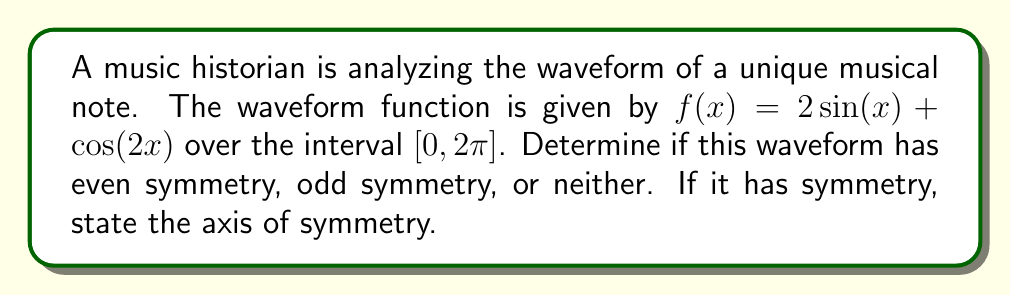Help me with this question. To determine the symmetry of the waveform function $f(x) = 2\sin(x) + \cos(2x)$, we need to check if it satisfies the conditions for even or odd symmetry:

1. Even symmetry: $f(-x) = f(x)$ for all $x$ in the domain
2. Odd symmetry: $f(-x) = -f(x)$ for all $x$ in the domain

Let's examine each term of the function:

1. $2\sin(x)$:
   $\sin(-x) = -\sin(x)$, so this term has odd symmetry.

2. $\cos(2x)$:
   $\cos(-2x) = \cos(2x)$, so this term has even symmetry.

Since the function is a sum of an odd function and an even function, it doesn't have overall even or odd symmetry.

However, we can check for symmetry about the y-axis (x = 0) or the origin:

For y-axis symmetry (even symmetry):
$f(-x) = 2\sin(-x) + \cos(-2x) = -2\sin(x) + \cos(2x) \neq f(x)$

For origin symmetry (odd symmetry):
$-f(-x) = -(2\sin(-x) + \cos(-2x)) = -(-2\sin(x) + \cos(2x)) = 2\sin(x) - \cos(2x) \neq f(x)$

Therefore, the function does not have even or odd symmetry about the y-axis or the origin.

However, we can observe that the function might have symmetry about the midpoint of the interval $[0, 2\pi]$, which is $x = \pi$. To check this:

Let $g(x) = f(x + \pi)$:

$g(x) = 2\sin(x + \pi) + \cos(2(x + \pi))$
$= -2\sin(x) + \cos(2x + 2\pi)$
$= -2\sin(x) + \cos(2x)$

Now, let's check if $g(-x) = f(x)$:

$g(-x) = -2\sin(-x) + \cos(-2x) = 2\sin(x) + \cos(2x) = f(x)$

This confirms that the function has even symmetry about the line $x = \pi$.
Answer: The waveform function $f(x) = 2\sin(x) + \cos(2x)$ has even symmetry about the line $x = \pi$. 